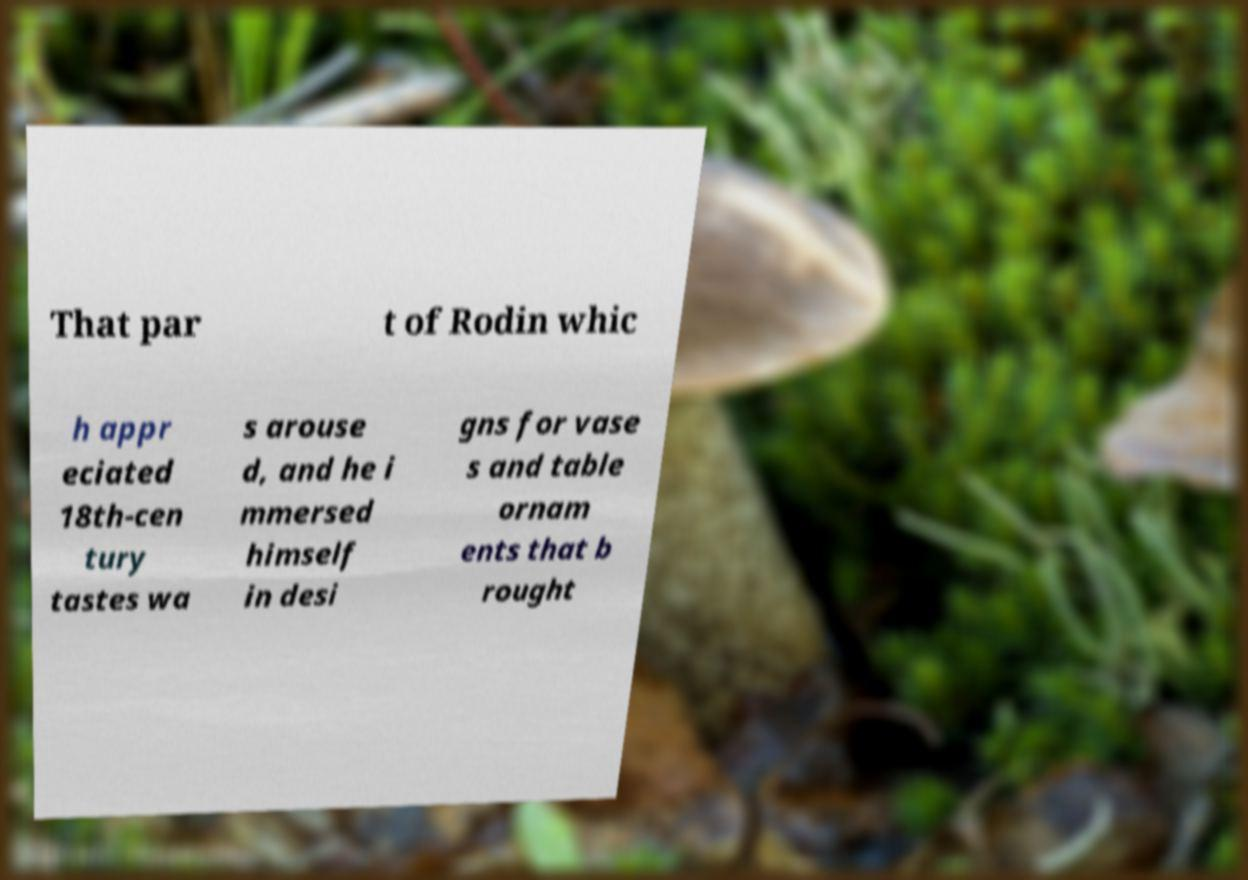There's text embedded in this image that I need extracted. Can you transcribe it verbatim? That par t of Rodin whic h appr eciated 18th-cen tury tastes wa s arouse d, and he i mmersed himself in desi gns for vase s and table ornam ents that b rought 